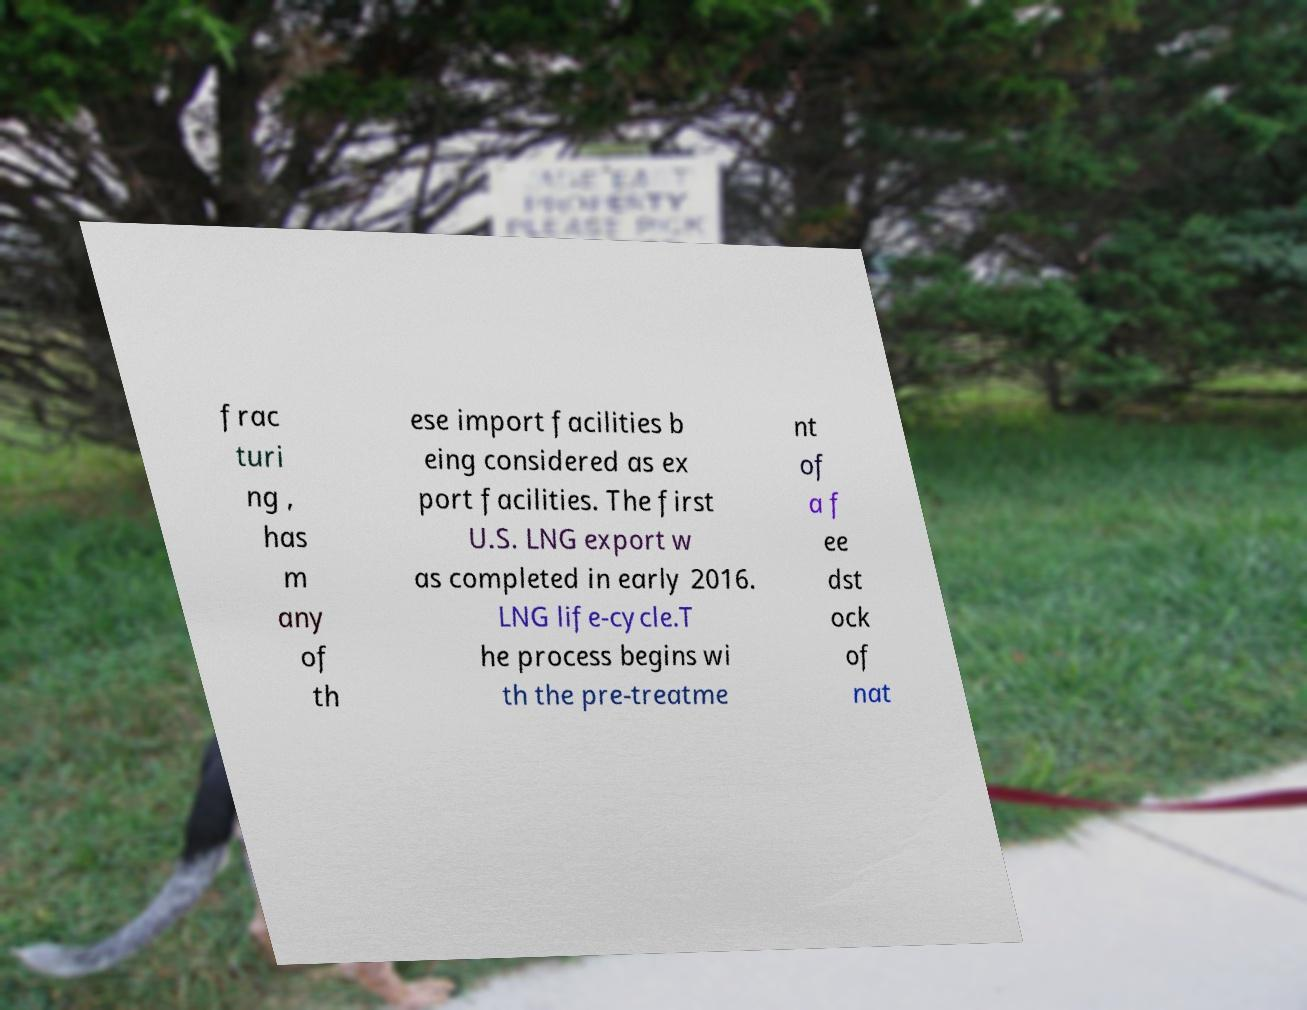I need the written content from this picture converted into text. Can you do that? frac turi ng , has m any of th ese import facilities b eing considered as ex port facilities. The first U.S. LNG export w as completed in early 2016. LNG life-cycle.T he process begins wi th the pre-treatme nt of a f ee dst ock of nat 